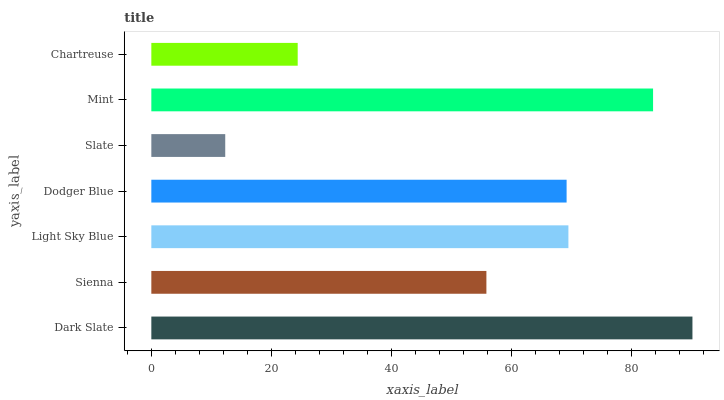Is Slate the minimum?
Answer yes or no. Yes. Is Dark Slate the maximum?
Answer yes or no. Yes. Is Sienna the minimum?
Answer yes or no. No. Is Sienna the maximum?
Answer yes or no. No. Is Dark Slate greater than Sienna?
Answer yes or no. Yes. Is Sienna less than Dark Slate?
Answer yes or no. Yes. Is Sienna greater than Dark Slate?
Answer yes or no. No. Is Dark Slate less than Sienna?
Answer yes or no. No. Is Dodger Blue the high median?
Answer yes or no. Yes. Is Dodger Blue the low median?
Answer yes or no. Yes. Is Slate the high median?
Answer yes or no. No. Is Light Sky Blue the low median?
Answer yes or no. No. 